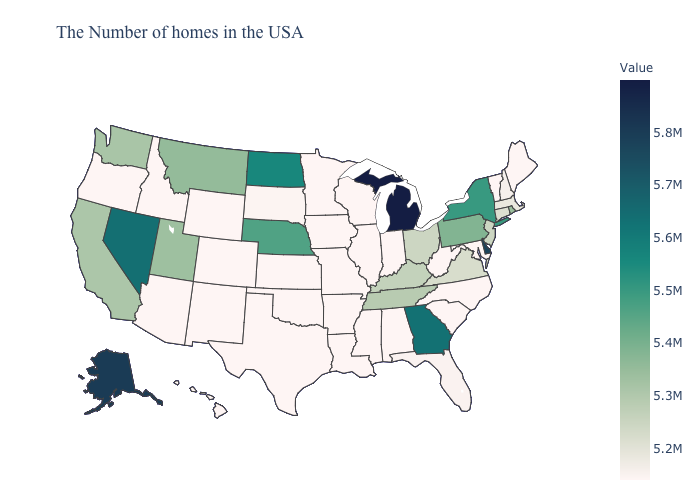Is the legend a continuous bar?
Quick response, please. Yes. Which states hav the highest value in the South?
Write a very short answer. Delaware. Does Nevada have the lowest value in the West?
Keep it brief. No. Which states have the lowest value in the USA?
Quick response, please. Maine, Vermont, Maryland, North Carolina, South Carolina, West Virginia, Indiana, Alabama, Wisconsin, Illinois, Mississippi, Louisiana, Missouri, Arkansas, Minnesota, Iowa, Kansas, Oklahoma, Texas, Wyoming, Colorado, New Mexico, Arizona, Idaho, Oregon, Hawaii. Among the states that border Delaware , which have the highest value?
Be succinct. Pennsylvania. Which states have the highest value in the USA?
Be succinct. Michigan. Among the states that border Montana , which have the highest value?
Answer briefly. North Dakota. 